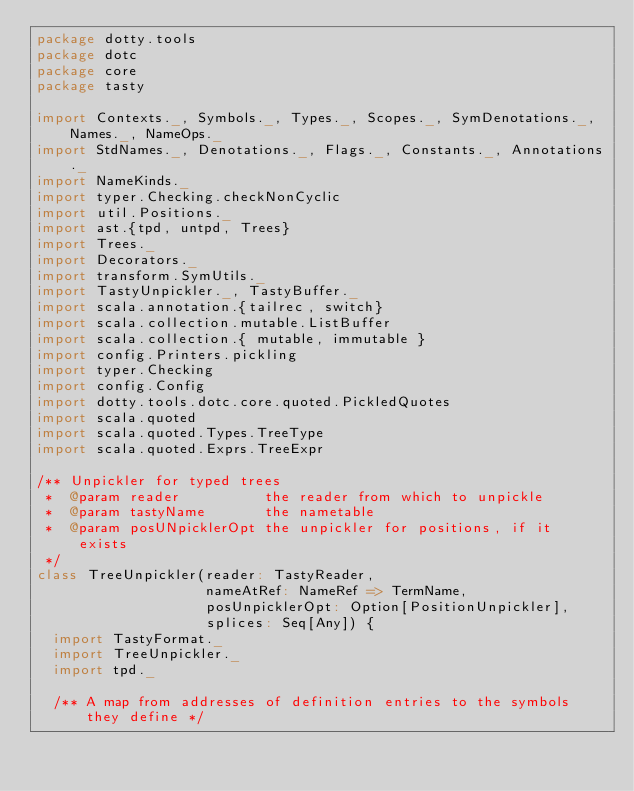<code> <loc_0><loc_0><loc_500><loc_500><_Scala_>package dotty.tools
package dotc
package core
package tasty

import Contexts._, Symbols._, Types._, Scopes._, SymDenotations._, Names._, NameOps._
import StdNames._, Denotations._, Flags._, Constants._, Annotations._
import NameKinds._
import typer.Checking.checkNonCyclic
import util.Positions._
import ast.{tpd, untpd, Trees}
import Trees._
import Decorators._
import transform.SymUtils._
import TastyUnpickler._, TastyBuffer._
import scala.annotation.{tailrec, switch}
import scala.collection.mutable.ListBuffer
import scala.collection.{ mutable, immutable }
import config.Printers.pickling
import typer.Checking
import config.Config
import dotty.tools.dotc.core.quoted.PickledQuotes
import scala.quoted
import scala.quoted.Types.TreeType
import scala.quoted.Exprs.TreeExpr

/** Unpickler for typed trees
 *  @param reader          the reader from which to unpickle
 *  @param tastyName       the nametable
 *  @param posUNpicklerOpt the unpickler for positions, if it exists
 */
class TreeUnpickler(reader: TastyReader,
                    nameAtRef: NameRef => TermName,
                    posUnpicklerOpt: Option[PositionUnpickler],
                    splices: Seq[Any]) {
  import TastyFormat._
  import TreeUnpickler._
  import tpd._

  /** A map from addresses of definition entries to the symbols they define */</code> 